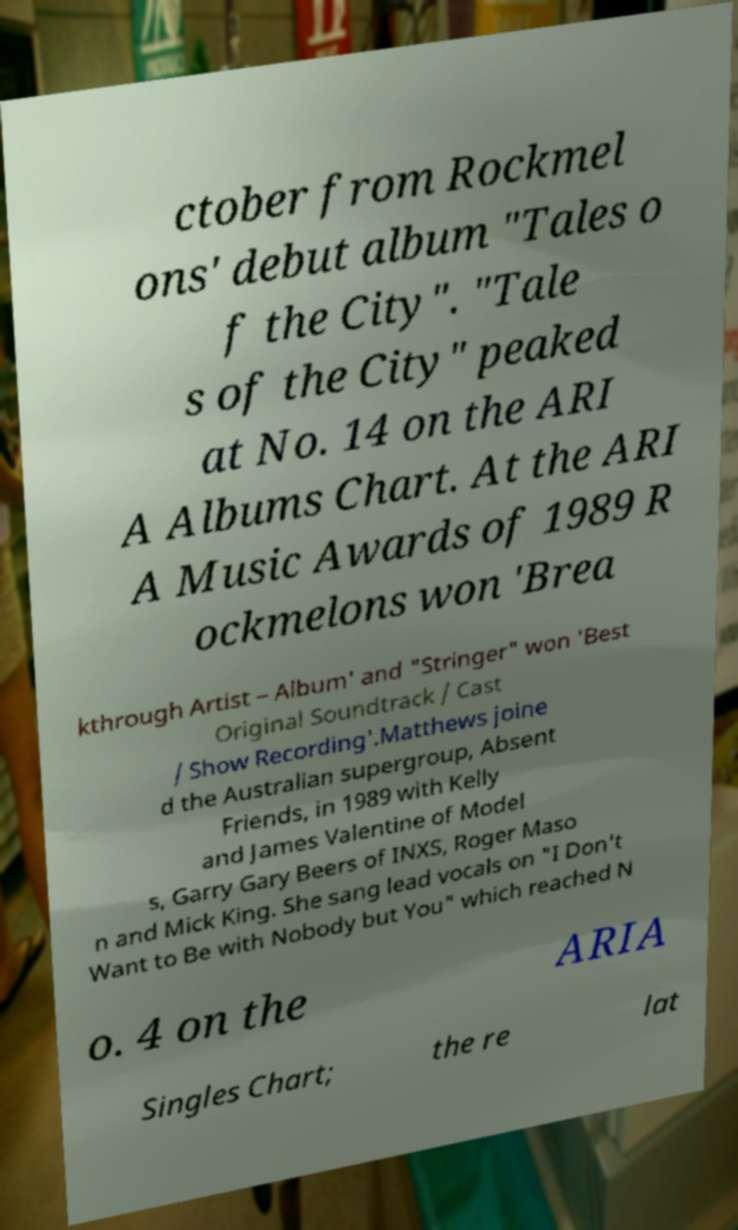I need the written content from this picture converted into text. Can you do that? ctober from Rockmel ons' debut album "Tales o f the City". "Tale s of the City" peaked at No. 14 on the ARI A Albums Chart. At the ARI A Music Awards of 1989 R ockmelons won 'Brea kthrough Artist – Album' and "Stringer" won 'Best Original Soundtrack / Cast / Show Recording'.Matthews joine d the Australian supergroup, Absent Friends, in 1989 with Kelly and James Valentine of Model s, Garry Gary Beers of INXS, Roger Maso n and Mick King. She sang lead vocals on "I Don't Want to Be with Nobody but You" which reached N o. 4 on the ARIA Singles Chart; the re lat 